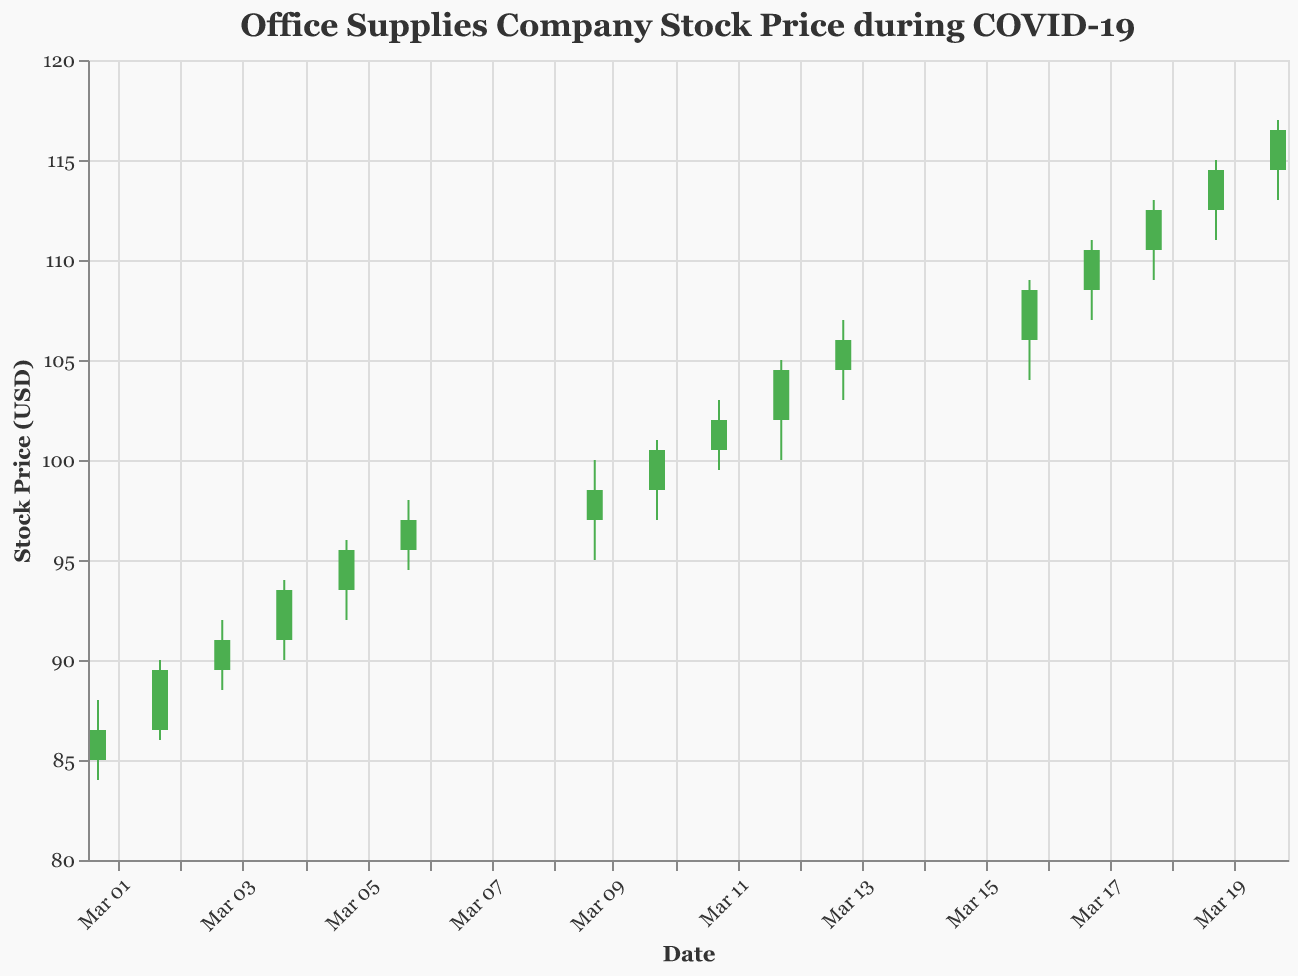What is the title of the figure? The title of the figure is displayed at the top and it reads "Office Supplies Company Stock Price during COVID-19".
Answer: Office Supplies Company Stock Price during COVID-19 When did the stock price have the highest closing price? The highest closing price can be found by examining the 'Close' column in the data. The highest closing price is $116.50, which occurred on March 20, 2020.
Answer: March 20, 2020 What was the volume of stocks traded on March 10, 2020? By looking at the data for March 10, 2020, the volume of stocks traded on this day was 3,400,000.
Answer: 3,400,000 Which day had the lowest low price and what was that price? By examining the 'Low' values in the data, the lowest price was $84.00 and it occurred on March 1, 2020.
Answer: March 1, 2020, $84.00 Did the stock price close higher or lower than it opened on March 4, 2020? For March 4, 2020, compare the open price ($91.00) and the close price ($93.50). The close price is higher than the open price.
Answer: Higher Compare the stock price on March 5, 2020, and March 12, 2020. Which day had a higher closing price? Look at the closing prices for both dates: March 5, 2020 had a close price of $95.50 and March 12, 2020 had a close price of $104.50. March 12, 2020 had a higher closing price.
Answer: March 12, 2020 How much did the stock price increase from March 1, 2020, to March 20, 2020? To find the increase, subtract the closing price on March 1, 2020 ($86.50) from the closing price on March 20, 2020 ($116.50). The increase is $116.50 - $86.50 = $30.00.
Answer: $30.00 How many days did the stock price close higher than it opened? Count the number of days where the closing price is greater than the opening price by examining the 'Open' and 'Close' columns. This occurs on 14 out of the 15 days in the dataset.
Answer: 14 days What is the average closing price over the provided period? To find the average closing price, sum all the closing prices and divide by the number of days. The sum of closing prices is $86.50 + $89.50 + $91.00 + $93.50 + $95.50 + $97.00 + $98.50 + $100.50 + $102.00 + $104.50 + $106.00 + $108.50 + $110.50 + $112.50 + $114.50 + $116.50 = $1567.00. The average is $1567.00 / 15 ≈ $104.47.
Answer: $104.47 